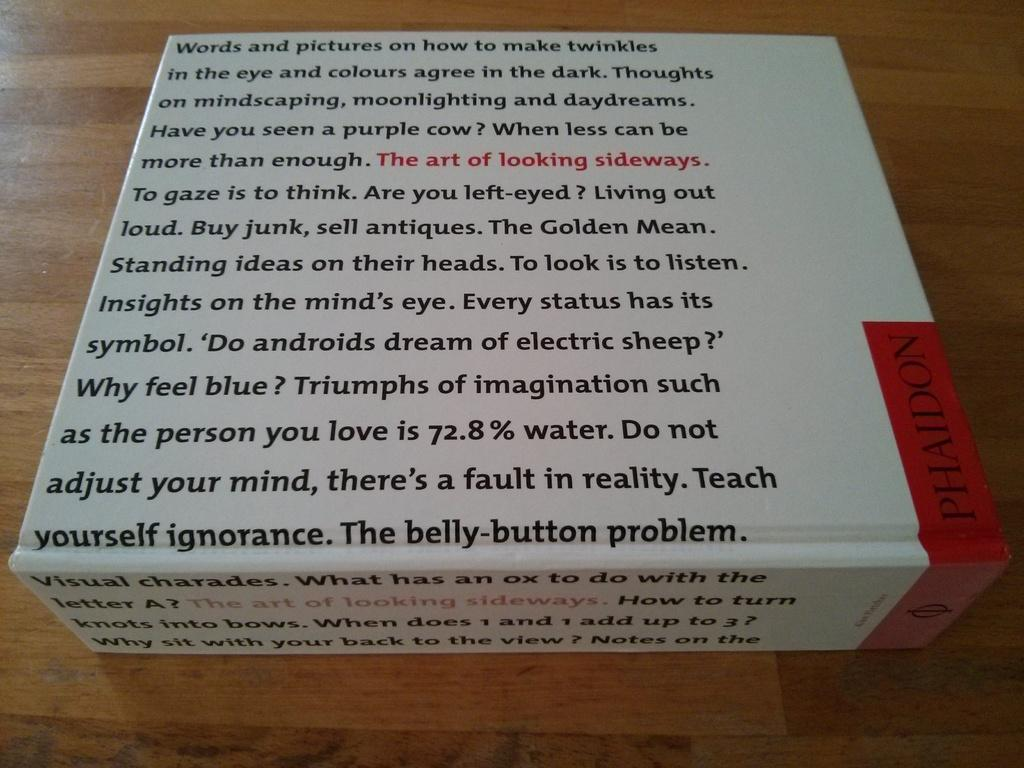What object is present on the table in the image? There is a box on the table in the image. What is the purpose of the writing on the box? The purpose of the writing on the box is not specified in the image, but it could be for labeling or branding. How does the zephyr affect the box in the image? There is no zephyr present in the image, so its effect on the box cannot be determined. 